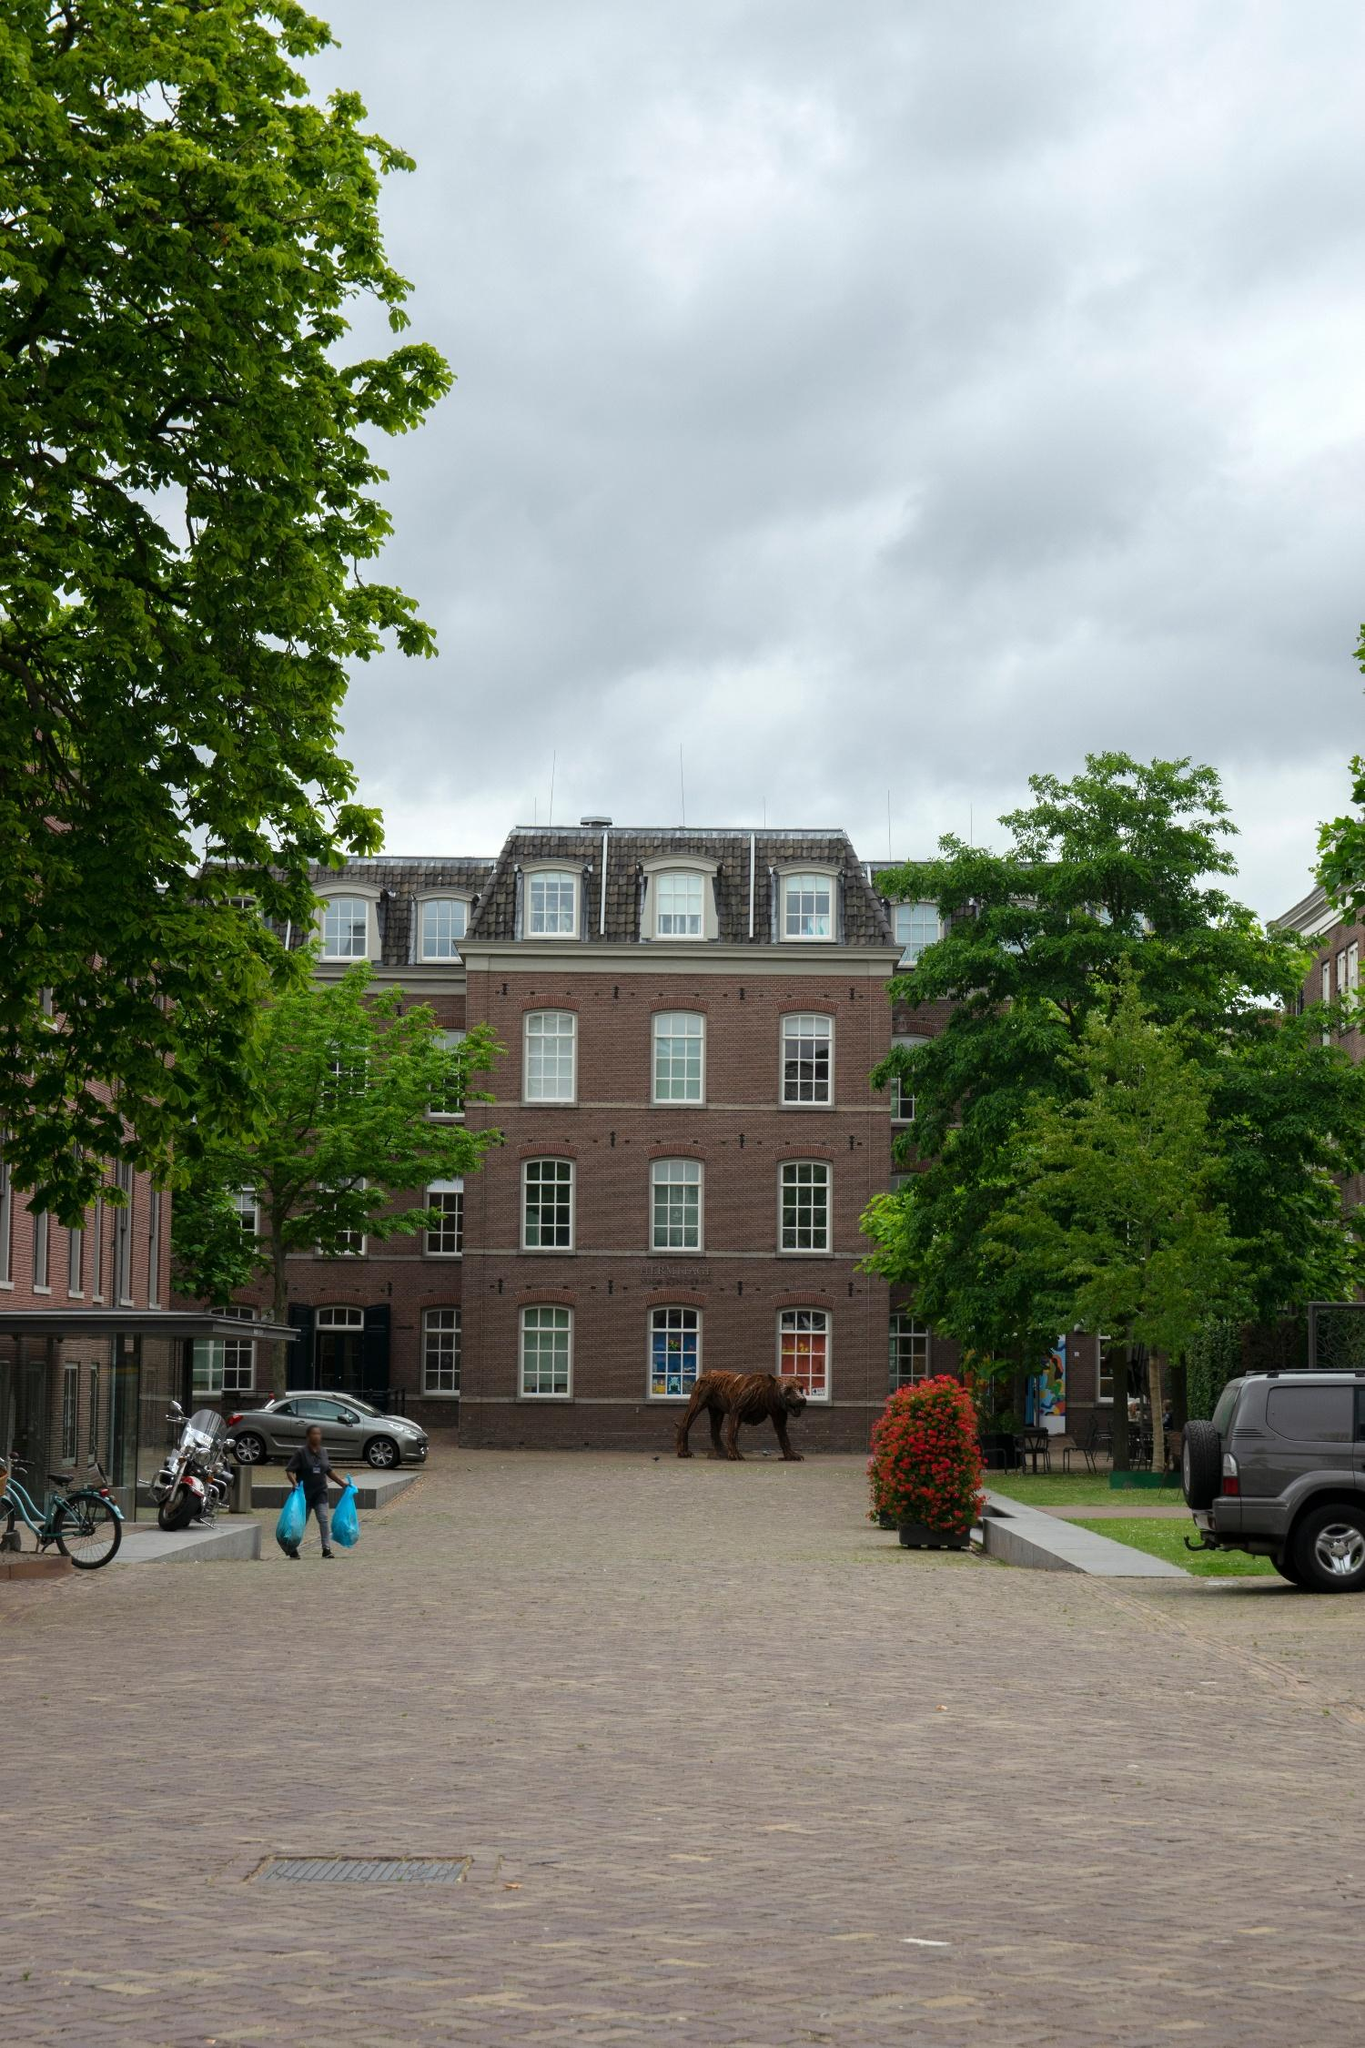What's your favorite detail about the image and why? One of the most striking details in the image is the brown sculpture of the bear. It adds a whimsical yet artistic touch to the otherwise residential and historical setting. This fusion of art and everyday life creates a narrative where the ordinary meets the extraordinary. The contrast between the natural elements—the trees and the clouds—with this man-made artifact sparks curiosity and invites viewers to delve deeper into the story behind the sculpture and its place in this serene neighborhood. What might be the significance of the sculpture in front of the building? The sculpture of the bear in front of the building might symbolize several things. It could be a public art installation aimed at adding character and charm to the neighborhood. Bears are often seen as symbols of strength and resilience, so it might be a community’s emblem of unity and fortitude. Alternatively, it could commemorate a local legend or historical event tied to the area. The placement of the sculpture encourages passersby to pause and reflect, creating a space where art and daily life intersect organically. 